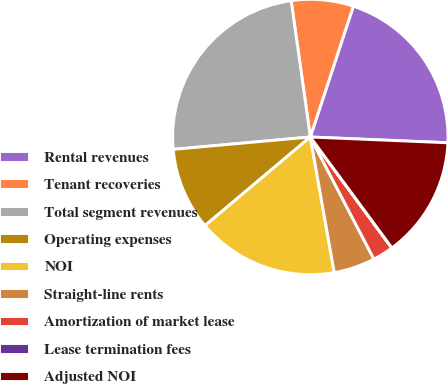Convert chart. <chart><loc_0><loc_0><loc_500><loc_500><pie_chart><fcel>Rental revenues<fcel>Tenant recoveries<fcel>Total segment revenues<fcel>Operating expenses<fcel>NOI<fcel>Straight-line rents<fcel>Amortization of market lease<fcel>Lease termination fees<fcel>Adjusted NOI<nl><fcel>20.61%<fcel>7.28%<fcel>24.21%<fcel>9.7%<fcel>16.65%<fcel>4.86%<fcel>2.44%<fcel>0.02%<fcel>14.23%<nl></chart> 